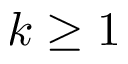<formula> <loc_0><loc_0><loc_500><loc_500>k \geq 1</formula> 